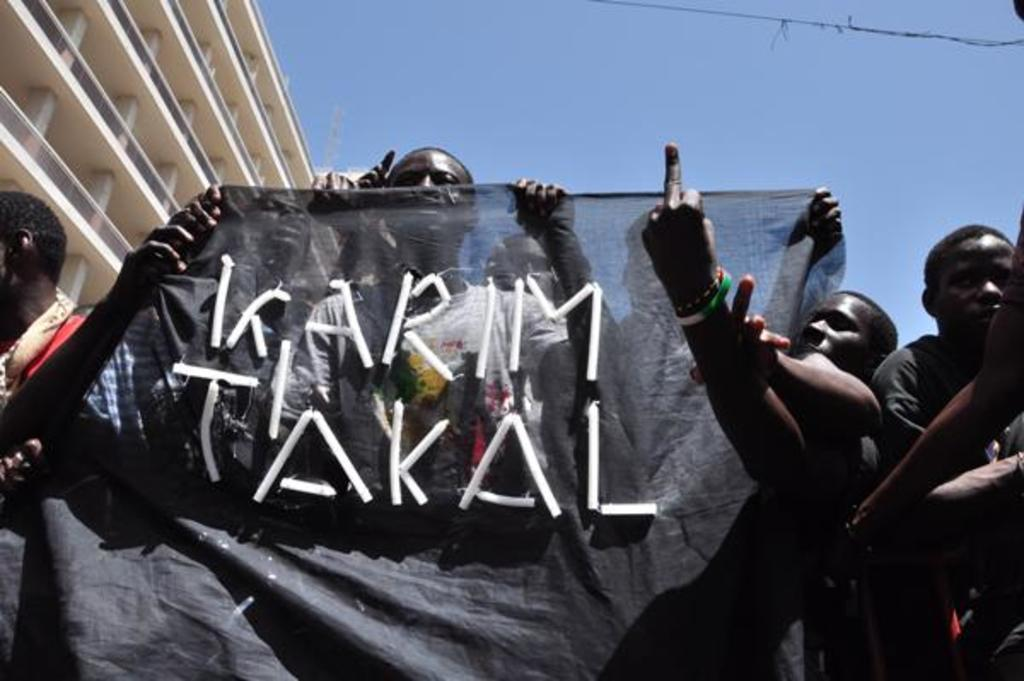What is the main structure visible in the image? There is a building in the image. Are there any people present in the image? Yes, there are people standing in the image. What are some of the people holding? Some of the people are holding a black cloth with text on it. What is the color of the sky in the image? The sky is blue in the image. Can you see a beetle crawling on the building in the image? There is no beetle visible in the image. What power source is being used by the people holding the black cloth? The image does not provide information about any power source being used by the people holding the black cloth. 